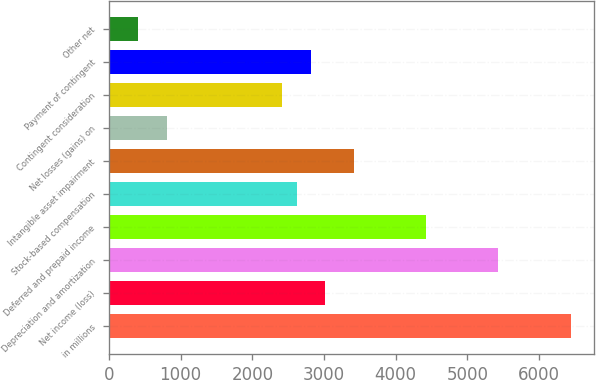<chart> <loc_0><loc_0><loc_500><loc_500><bar_chart><fcel>in millions<fcel>Net income (loss)<fcel>Depreciation and amortization<fcel>Deferred and prepaid income<fcel>Stock-based compensation<fcel>Intangible asset impairment<fcel>Net losses (gains) on<fcel>Contingent consideration<fcel>Payment of contingent<fcel>Other net<nl><fcel>6438.2<fcel>3019.5<fcel>5432.7<fcel>4427.2<fcel>2617.3<fcel>3421.7<fcel>807.4<fcel>2416.2<fcel>2818.4<fcel>405.2<nl></chart> 